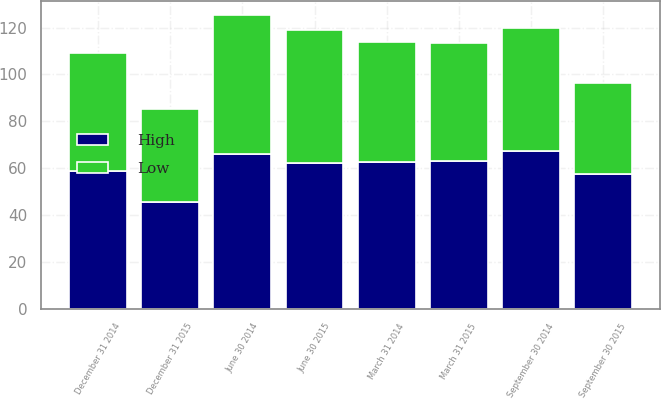<chart> <loc_0><loc_0><loc_500><loc_500><stacked_bar_chart><ecel><fcel>March 31 2014<fcel>June 30 2014<fcel>September 30 2014<fcel>December 31 2014<fcel>March 31 2015<fcel>June 30 2015<fcel>September 30 2015<fcel>December 31 2015<nl><fcel>High<fcel>62.42<fcel>66.16<fcel>67.38<fcel>58.75<fcel>63.01<fcel>62.08<fcel>57.65<fcel>45.53<nl><fcel>Low<fcel>51.32<fcel>59.06<fcel>52.61<fcel>50.24<fcel>50.46<fcel>56.84<fcel>38.89<fcel>39.82<nl></chart> 